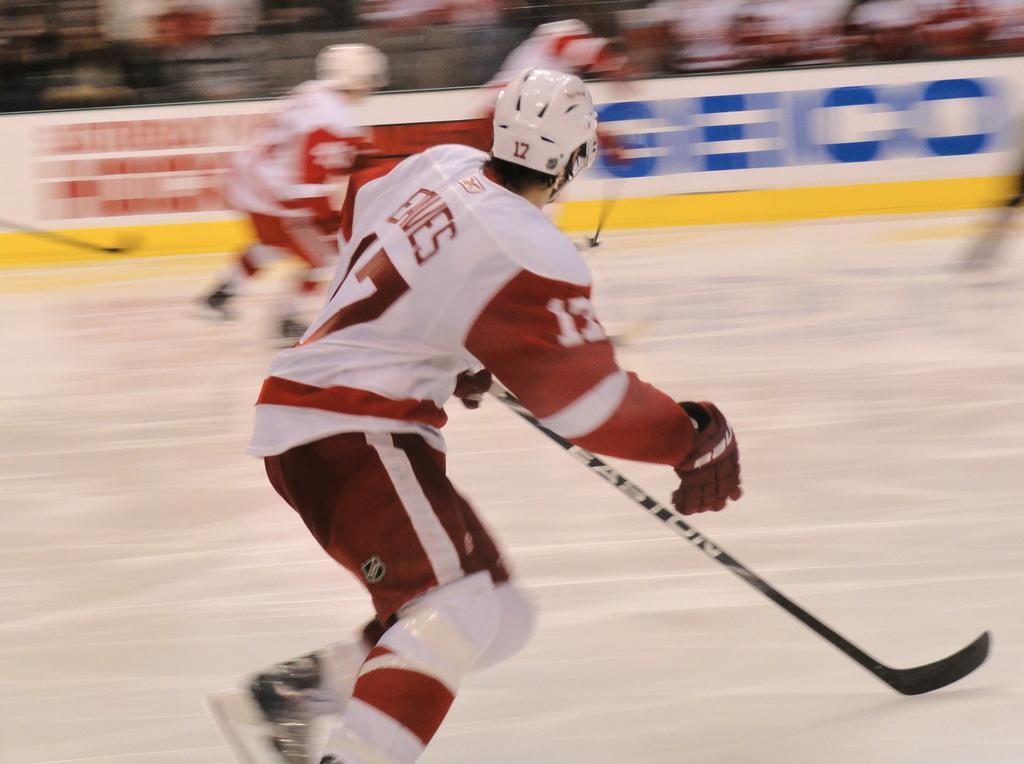Could you give a brief overview of what you see in this image? In this image I can see a person holding sticks and wearing helmet and running on floor and in the middle I can see the fence. 